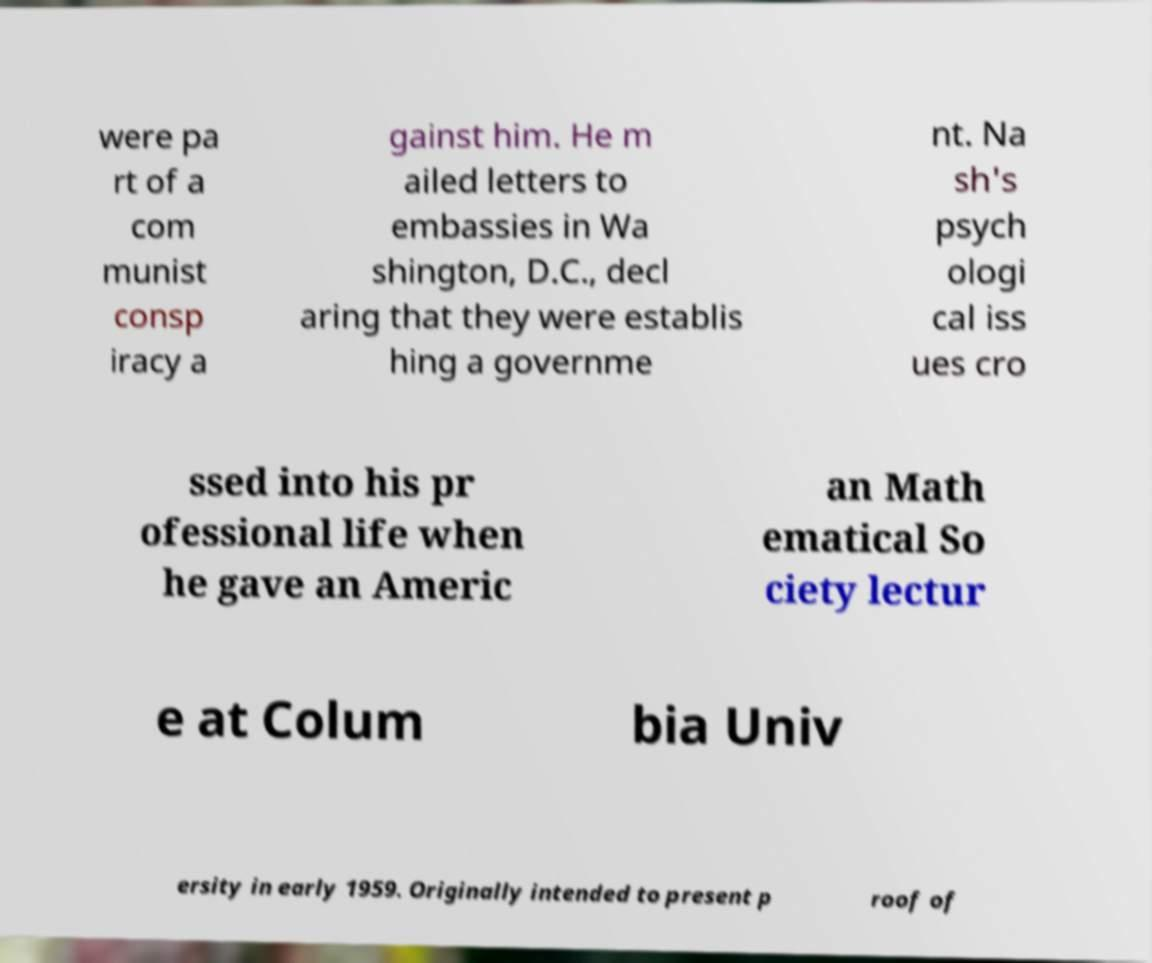Could you extract and type out the text from this image? were pa rt of a com munist consp iracy a gainst him. He m ailed letters to embassies in Wa shington, D.C., decl aring that they were establis hing a governme nt. Na sh's psych ologi cal iss ues cro ssed into his pr ofessional life when he gave an Americ an Math ematical So ciety lectur e at Colum bia Univ ersity in early 1959. Originally intended to present p roof of 